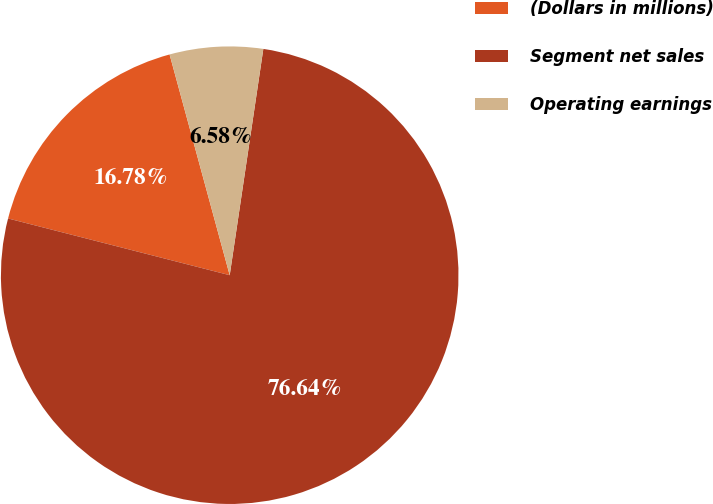<chart> <loc_0><loc_0><loc_500><loc_500><pie_chart><fcel>(Dollars in millions)<fcel>Segment net sales<fcel>Operating earnings<nl><fcel>16.78%<fcel>76.64%<fcel>6.58%<nl></chart> 